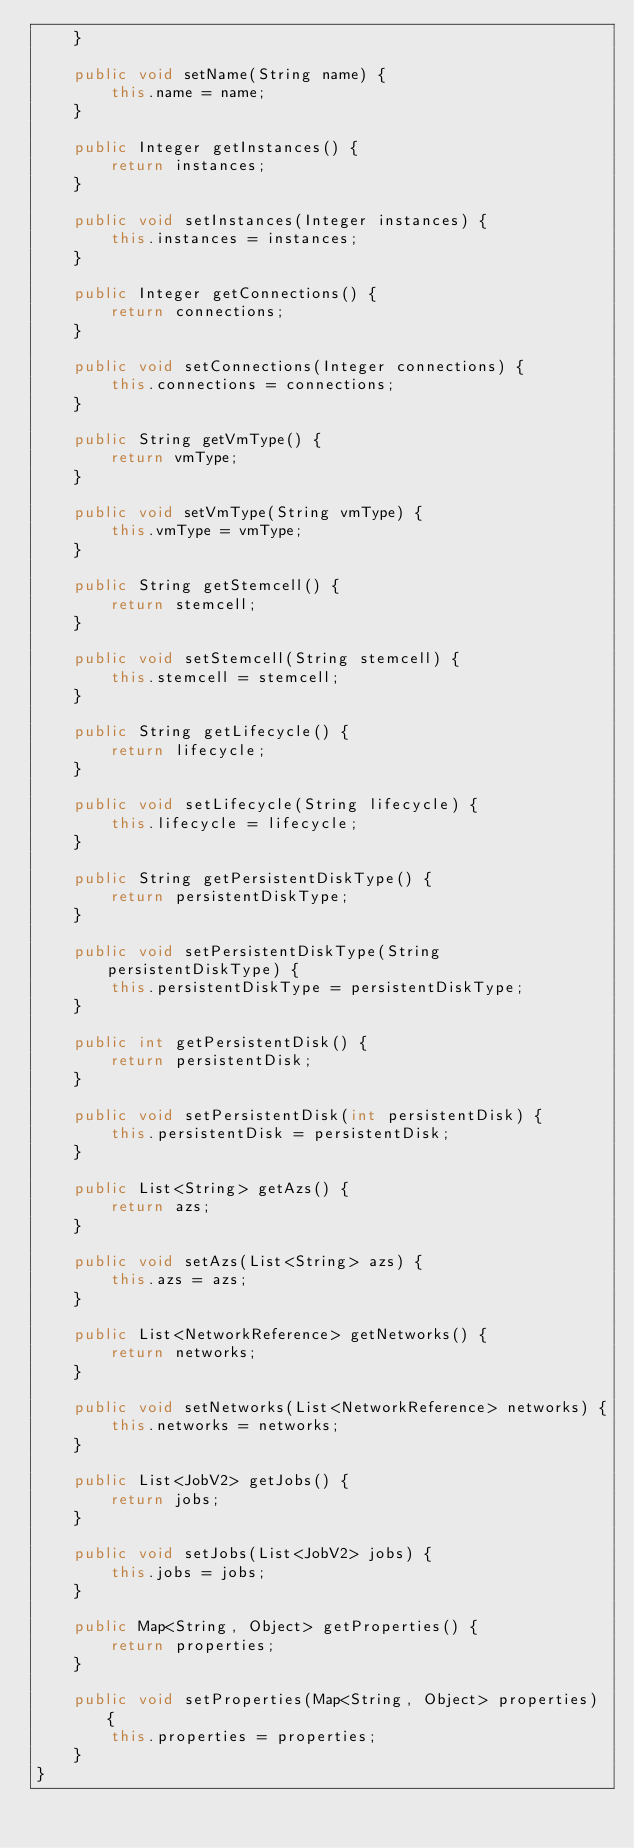<code> <loc_0><loc_0><loc_500><loc_500><_Java_>    }

    public void setName(String name) {
        this.name = name;
    }

    public Integer getInstances() {
        return instances;
    }

    public void setInstances(Integer instances) {
        this.instances = instances;
    }

    public Integer getConnections() {
        return connections;
    }

    public void setConnections(Integer connections) {
        this.connections = connections;
    }

    public String getVmType() {
        return vmType;
    }

    public void setVmType(String vmType) {
        this.vmType = vmType;
    }

    public String getStemcell() {
        return stemcell;
    }

    public void setStemcell(String stemcell) {
        this.stemcell = stemcell;
    }

    public String getLifecycle() {
        return lifecycle;
    }

    public void setLifecycle(String lifecycle) {
        this.lifecycle = lifecycle;
    }

    public String getPersistentDiskType() {
        return persistentDiskType;
    }

    public void setPersistentDiskType(String persistentDiskType) {
        this.persistentDiskType = persistentDiskType;
    }

    public int getPersistentDisk() {
        return persistentDisk;
    }

    public void setPersistentDisk(int persistentDisk) {
        this.persistentDisk = persistentDisk;
    }

    public List<String> getAzs() {
        return azs;
    }

    public void setAzs(List<String> azs) {
        this.azs = azs;
    }

    public List<NetworkReference> getNetworks() {
        return networks;
    }

    public void setNetworks(List<NetworkReference> networks) {
        this.networks = networks;
    }

    public List<JobV2> getJobs() {
        return jobs;
    }

    public void setJobs(List<JobV2> jobs) {
        this.jobs = jobs;
    }

    public Map<String, Object> getProperties() {
        return properties;
    }

    public void setProperties(Map<String, Object> properties) {
        this.properties = properties;
    }
}
</code> 